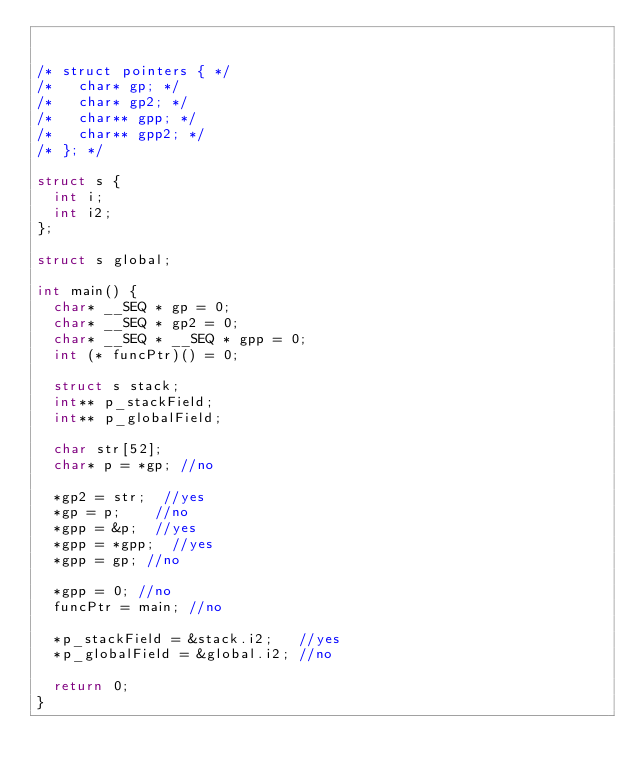<code> <loc_0><loc_0><loc_500><loc_500><_C_>

/* struct pointers { */
/*   char* gp; */
/*   char* gp2; */
/*   char** gpp; */
/*   char** gpp2; */
/* }; */

struct s {
  int i;
  int i2;
};

struct s global;

int main() {
  char* __SEQ * gp = 0;
  char* __SEQ * gp2 = 0;
  char* __SEQ * __SEQ * gpp = 0;
  int (* funcPtr)() = 0;

  struct s stack;
  int** p_stackField;
  int** p_globalField;

  char str[52];
  char* p = *gp; //no

  *gp2 = str;  //yes
  *gp = p;    //no
  *gpp = &p;  //yes
  *gpp = *gpp;  //yes
  *gpp = gp; //no

  *gpp = 0; //no
  funcPtr = main; //no

  *p_stackField = &stack.i2;   //yes
  *p_globalField = &global.i2; //no

  return 0;
}
</code> 